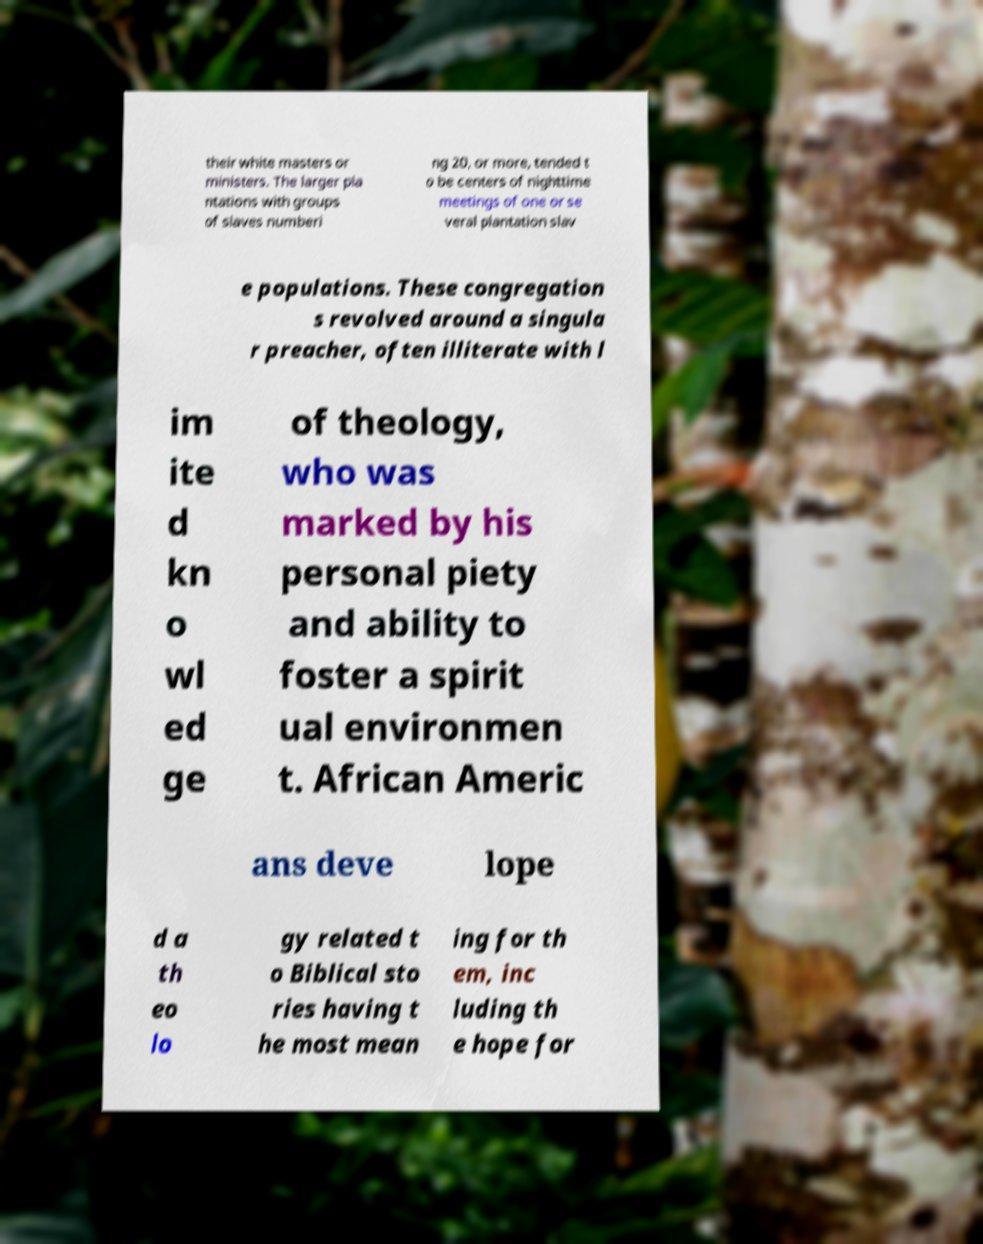For documentation purposes, I need the text within this image transcribed. Could you provide that? their white masters or ministers. The larger pla ntations with groups of slaves numberi ng 20, or more, tended t o be centers of nighttime meetings of one or se veral plantation slav e populations. These congregation s revolved around a singula r preacher, often illiterate with l im ite d kn o wl ed ge of theology, who was marked by his personal piety and ability to foster a spirit ual environmen t. African Americ ans deve lope d a th eo lo gy related t o Biblical sto ries having t he most mean ing for th em, inc luding th e hope for 